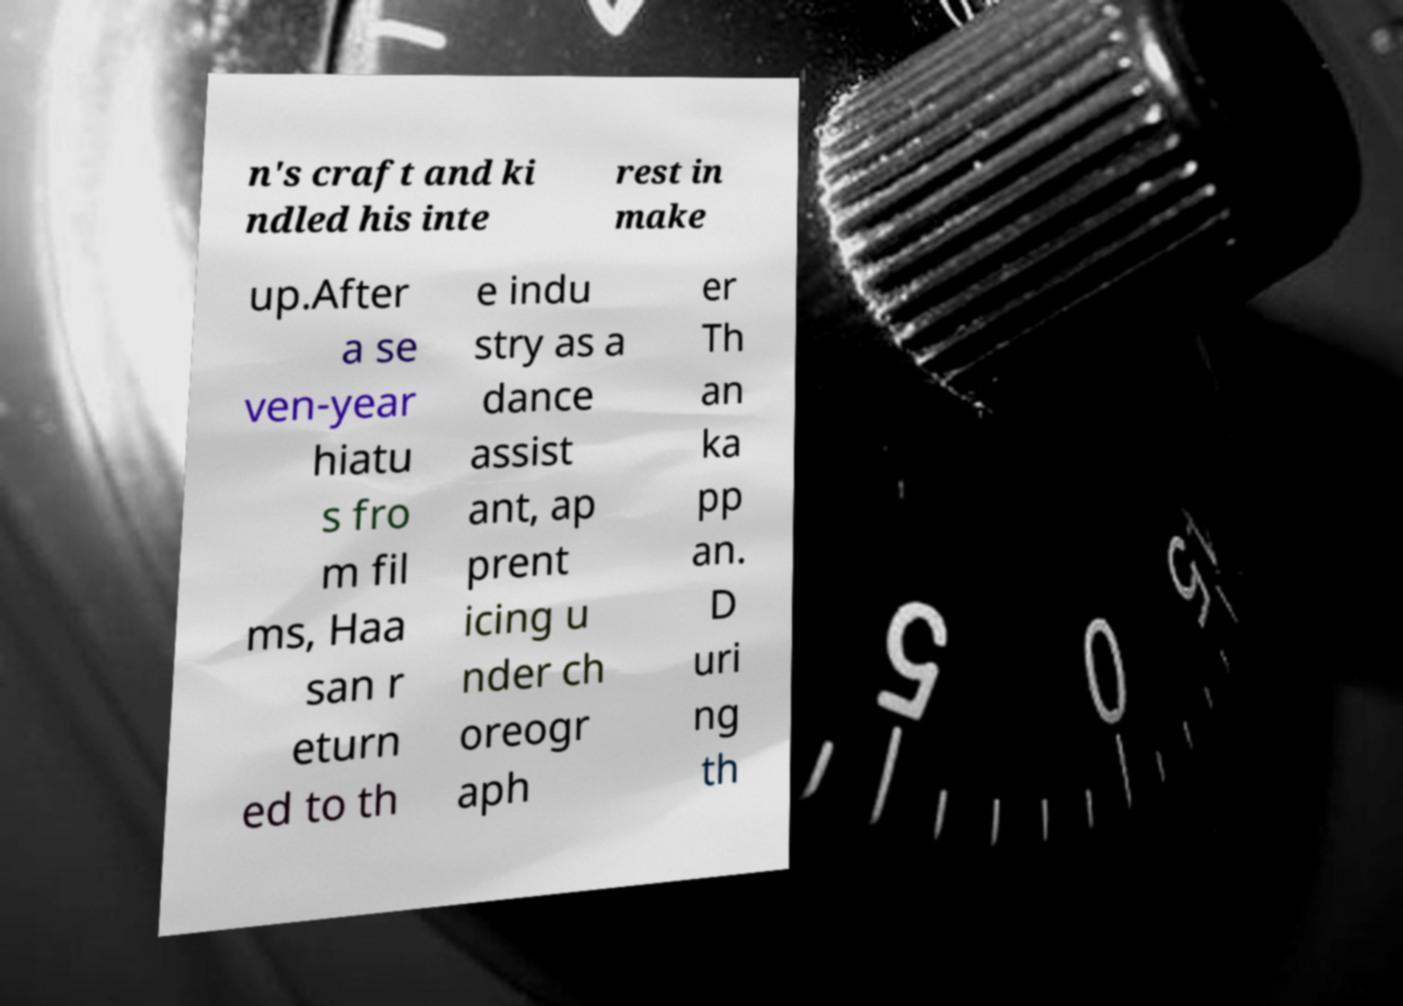Could you assist in decoding the text presented in this image and type it out clearly? n's craft and ki ndled his inte rest in make up.After a se ven-year hiatu s fro m fil ms, Haa san r eturn ed to th e indu stry as a dance assist ant, ap prent icing u nder ch oreogr aph er Th an ka pp an. D uri ng th 